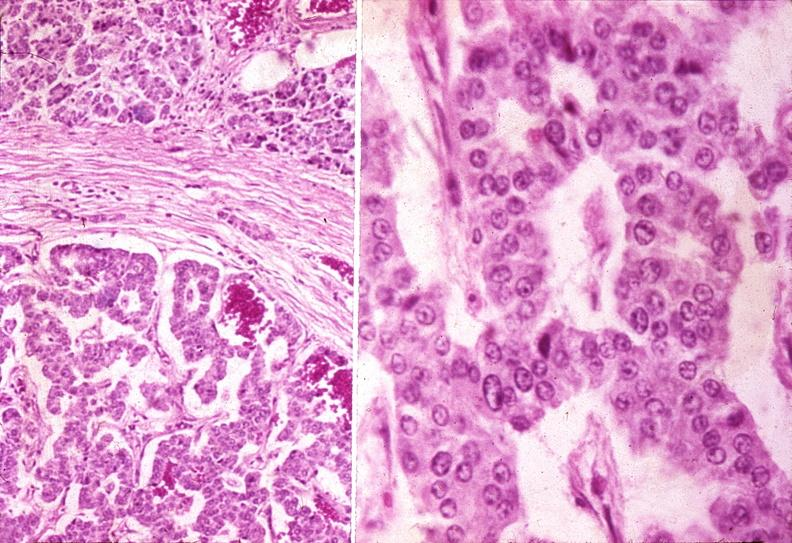s slices of liver and spleen typical tuberculous exudate is present on capsule of liver and spleen present?
Answer the question using a single word or phrase. No 